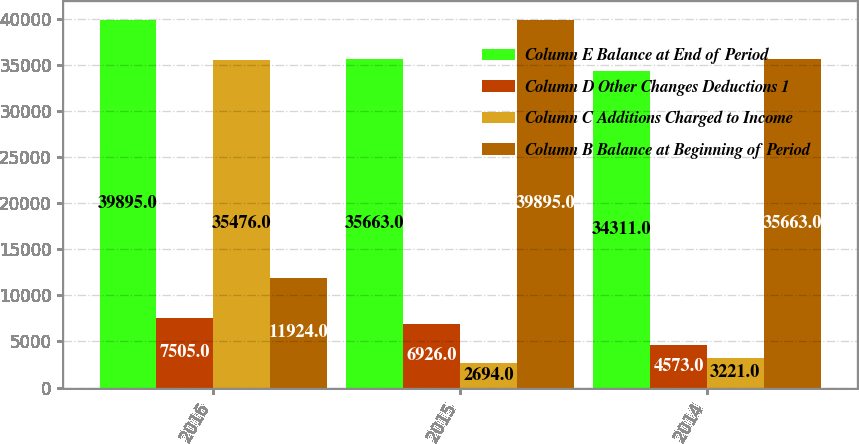Convert chart. <chart><loc_0><loc_0><loc_500><loc_500><stacked_bar_chart><ecel><fcel>2016<fcel>2015<fcel>2014<nl><fcel>Column E Balance at End of Period<fcel>39895<fcel>35663<fcel>34311<nl><fcel>Column D Other Changes Deductions 1<fcel>7505<fcel>6926<fcel>4573<nl><fcel>Column C Additions Charged to Income<fcel>35476<fcel>2694<fcel>3221<nl><fcel>Column B Balance at Beginning of Period<fcel>11924<fcel>39895<fcel>35663<nl></chart> 